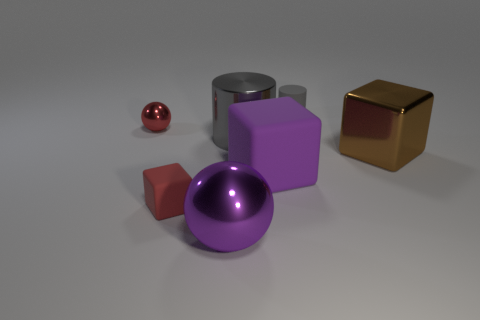There is a cube that is on the left side of the shiny sphere that is in front of the tiny shiny thing; how big is it?
Provide a short and direct response. Small. Are there the same number of metallic objects in front of the large matte block and large brown things behind the big metal block?
Your answer should be very brief. No. What is the material of the thing that is on the right side of the purple matte object and behind the shiny cube?
Your response must be concise. Rubber. Do the gray metal thing and the thing behind the small shiny ball have the same size?
Provide a short and direct response. No. What number of other objects are the same color as the tiny cylinder?
Provide a short and direct response. 1. Is the number of small red objects in front of the big metallic cylinder greater than the number of large green metallic cylinders?
Provide a succinct answer. Yes. The tiny rubber object in front of the small red object that is behind the big object right of the tiny rubber cylinder is what color?
Your answer should be compact. Red. Is the red block made of the same material as the large gray cylinder?
Provide a short and direct response. No. Is there a yellow rubber cylinder of the same size as the gray shiny cylinder?
Your response must be concise. No. There is a ball that is the same size as the gray metallic thing; what is its material?
Make the answer very short. Metal. 